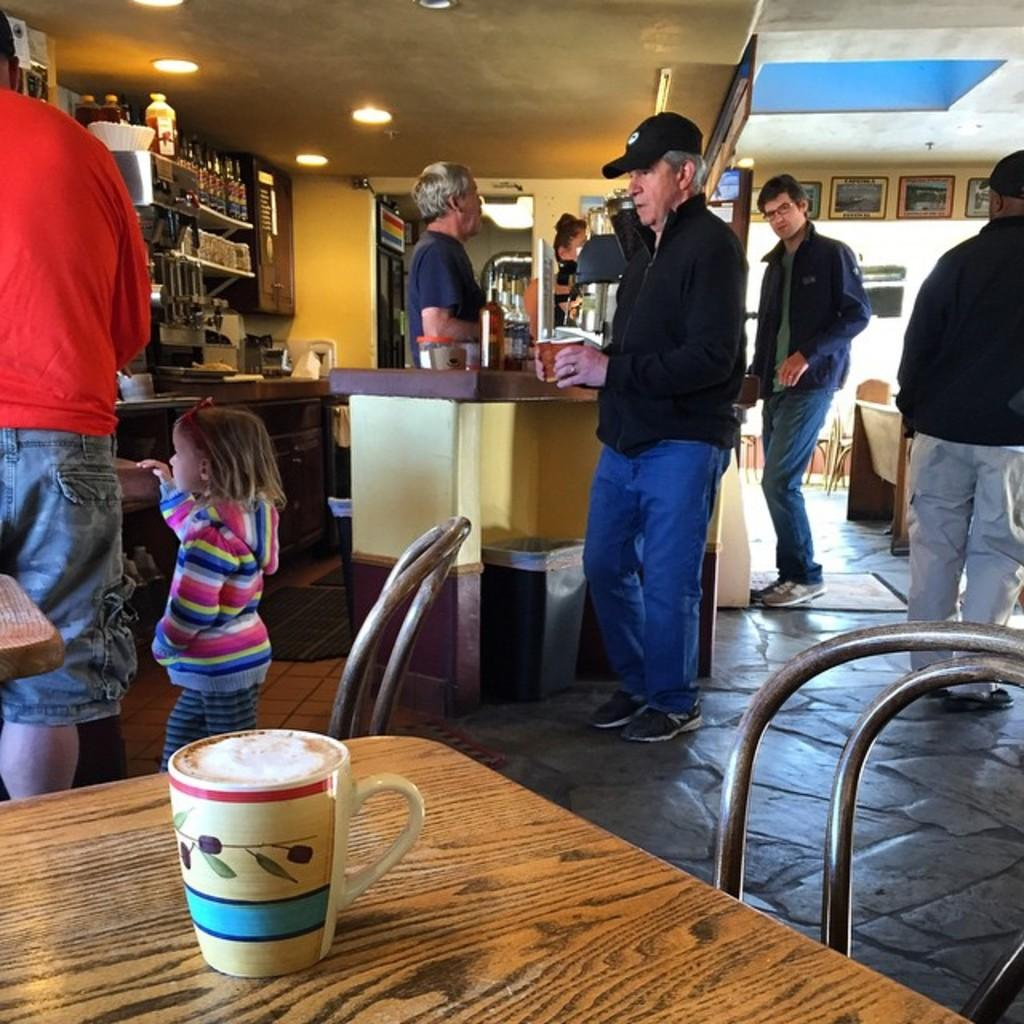How many people are present in the image? There are many people in the image. What are some people holding in the image? Some people are holding cups in the image. Can you describe the baby girl in the image? The baby girl is in the image, and she is standing with a man. Where is the coffee cup located in the image? The coffee cup is on a table in the image. What type of airplane is the baby girl flying in the image? There is no airplane present in the image; the baby girl is standing with a man. What nation is represented by the people in the image? The image does not provide information about the nationality of the people. 